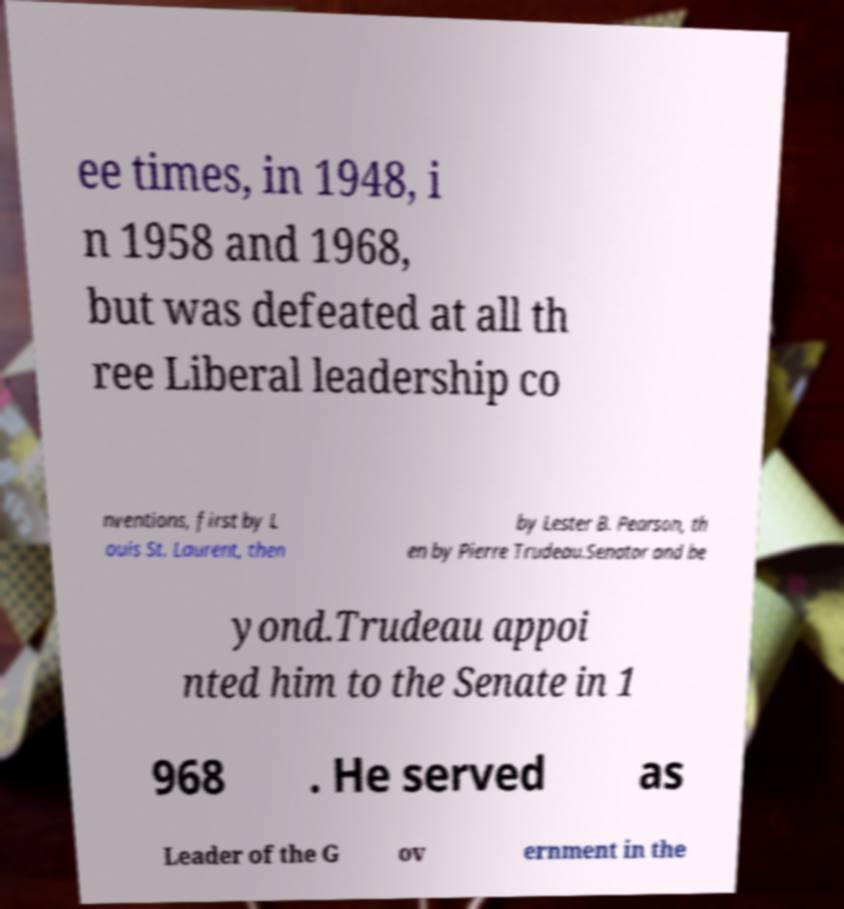There's text embedded in this image that I need extracted. Can you transcribe it verbatim? ee times, in 1948, i n 1958 and 1968, but was defeated at all th ree Liberal leadership co nventions, first by L ouis St. Laurent, then by Lester B. Pearson, th en by Pierre Trudeau.Senator and be yond.Trudeau appoi nted him to the Senate in 1 968 . He served as Leader of the G ov ernment in the 